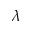Convert formula to latex. <formula><loc_0><loc_0><loc_500><loc_500>\lambda</formula> 